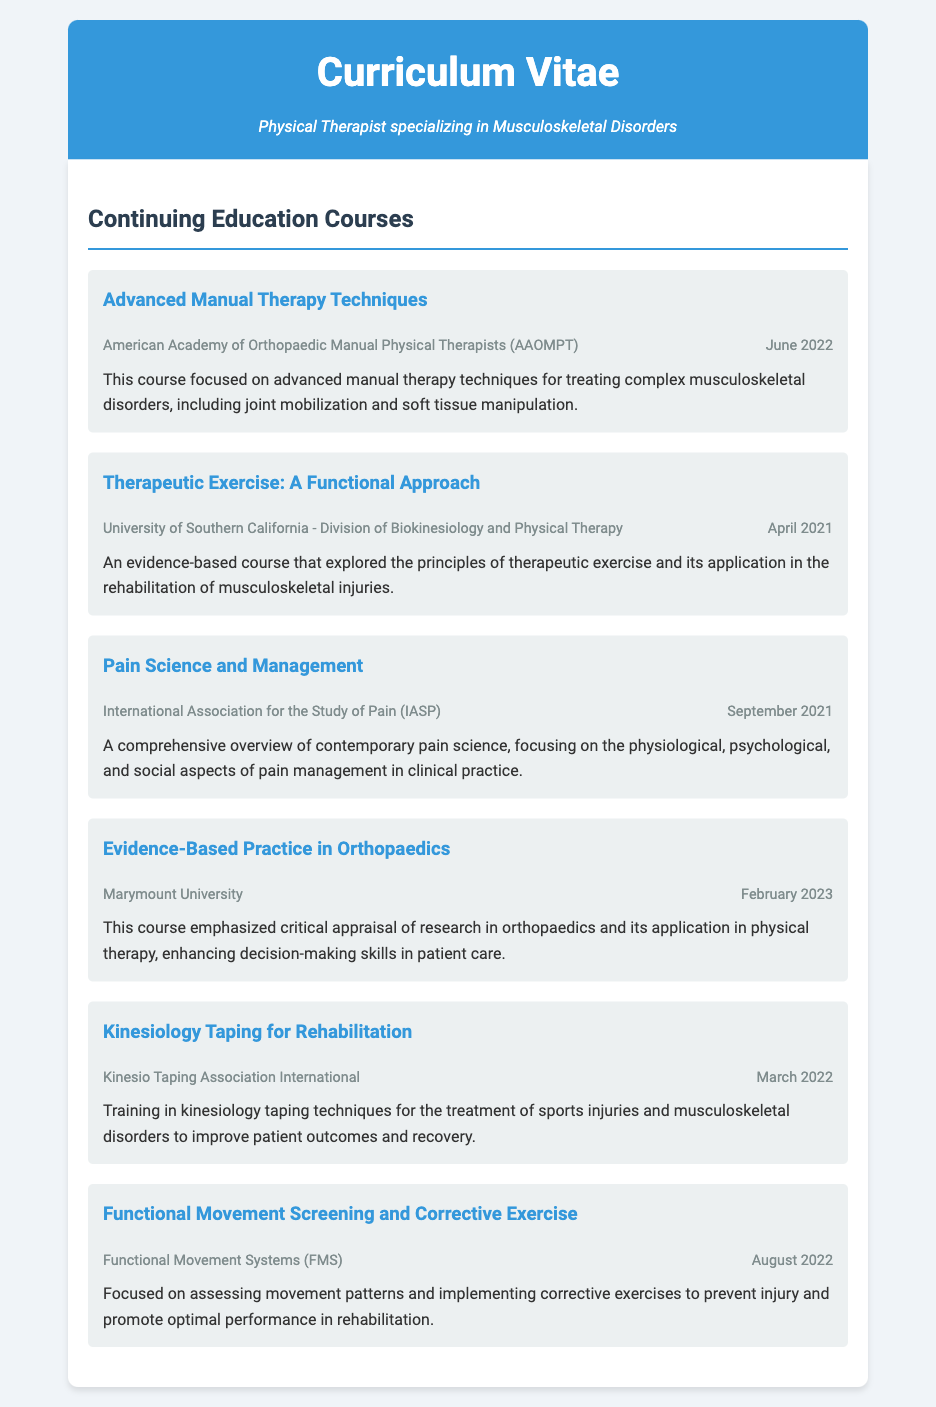what is the title of the first course listed? The first course listed is titled "Advanced Manual Therapy Techniques."
Answer: Advanced Manual Therapy Techniques who provided the course on therapeutic exercise? The course on therapeutic exercise was provided by the University of Southern California - Division of Biokinesiology and Physical Therapy.
Answer: University of Southern California - Division of Biokinesiology and Physical Therapy when was the course on pain science completed? The course on pain science was completed in September 2021.
Answer: September 2021 how many courses are listed in total? There are a total of six courses listed in the document.
Answer: Six what is the focus of the course titled "Functional Movement Screening and Corrective Exercise"? The focus of this course is on assessing movement patterns and implementing corrective exercises.
Answer: Assessing movement patterns and implementing corrective exercises which organization conducted the course on kinesiology taping? The course on kinesiology taping was conducted by the Kinesio Taping Association International.
Answer: Kinesio Taping Association International what month and year was the "Evidence-Based Practice in Orthopaedics" course completed? The "Evidence-Based Practice in Orthopaedics" course was completed in February 2023.
Answer: February 2023 what is the main purpose of the "Pain Science and Management" course? The main purpose is to provide an overview of contemporary pain science focusing on pain management.
Answer: Overview of contemporary pain science focusing on pain management 